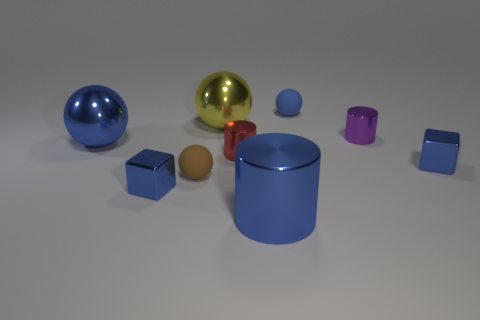There is a small rubber thing that is to the right of the small red shiny object; is it the same color as the big metallic cylinder?
Ensure brevity in your answer.  Yes. There is a small blue cube left of the big blue object on the right side of the red metal cylinder; how many tiny purple things are in front of it?
Make the answer very short. 0. What number of small spheres are both behind the big yellow thing and on the left side of the yellow metallic object?
Provide a succinct answer. 0. There is a matte thing that is the same color as the big cylinder; what shape is it?
Make the answer very short. Sphere. Are there any other things that are made of the same material as the small brown ball?
Offer a terse response. Yes. Do the red cylinder and the brown sphere have the same material?
Give a very brief answer. No. What shape is the matte object that is to the left of the sphere right of the large thing behind the purple thing?
Give a very brief answer. Sphere. Are there fewer small blue matte things that are to the left of the blue matte object than blue metal cylinders that are behind the large yellow ball?
Offer a very short reply. No. What is the shape of the blue thing that is right of the matte object behind the brown object?
Ensure brevity in your answer.  Cube. What number of blue objects are either matte objects or matte cylinders?
Provide a succinct answer. 1. 